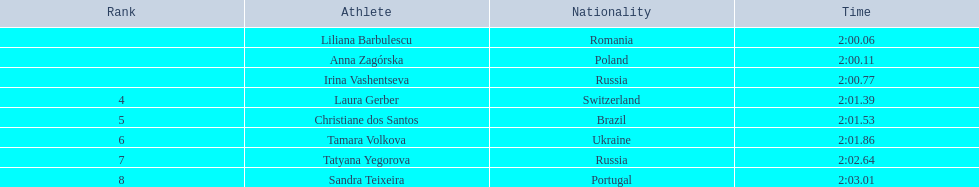Which athletes competed in the 2003 summer universiade - women's 800 metres? Liliana Barbulescu, Anna Zagórska, Irina Vashentseva, Laura Gerber, Christiane dos Santos, Tamara Volkova, Tatyana Yegorova, Sandra Teixeira. Of these, which are from poland? Anna Zagórska. What is her time? 2:00.11. 